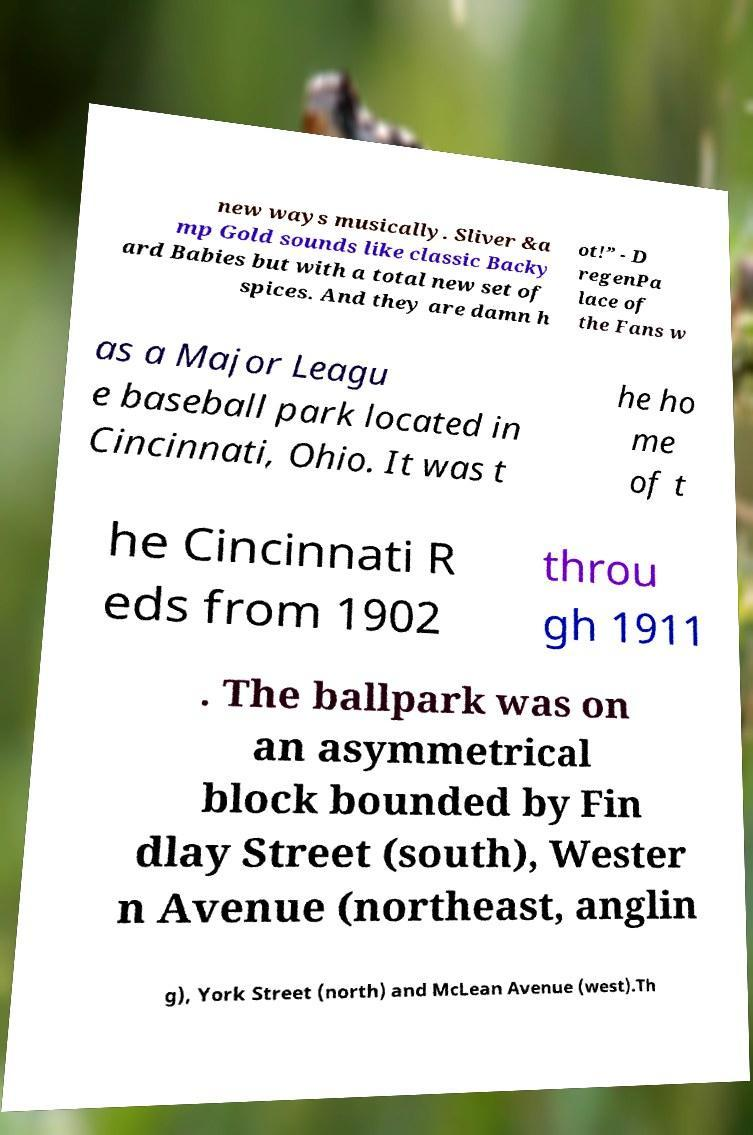For documentation purposes, I need the text within this image transcribed. Could you provide that? new ways musically. Sliver &a mp Gold sounds like classic Backy ard Babies but with a total new set of spices. And they are damn h ot!” - D regenPa lace of the Fans w as a Major Leagu e baseball park located in Cincinnati, Ohio. It was t he ho me of t he Cincinnati R eds from 1902 throu gh 1911 . The ballpark was on an asymmetrical block bounded by Fin dlay Street (south), Wester n Avenue (northeast, anglin g), York Street (north) and McLean Avenue (west).Th 